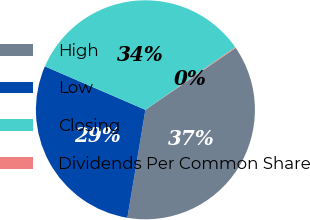Convert chart. <chart><loc_0><loc_0><loc_500><loc_500><pie_chart><fcel>High<fcel>Low<fcel>Closing<fcel>Dividends Per Common Share<nl><fcel>37.2%<fcel>28.86%<fcel>33.83%<fcel>0.11%<nl></chart> 